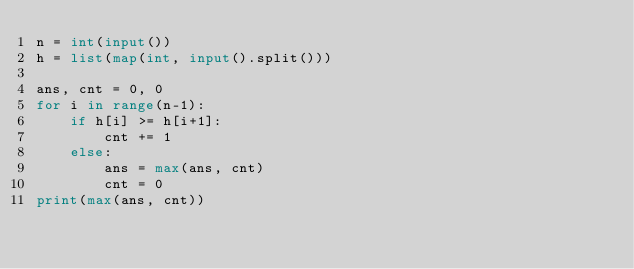<code> <loc_0><loc_0><loc_500><loc_500><_Python_>n = int(input())
h = list(map(int, input().split()))

ans, cnt = 0, 0
for i in range(n-1):
    if h[i] >= h[i+1]:
        cnt += 1
    else:
        ans = max(ans, cnt)
        cnt = 0
print(max(ans, cnt))</code> 